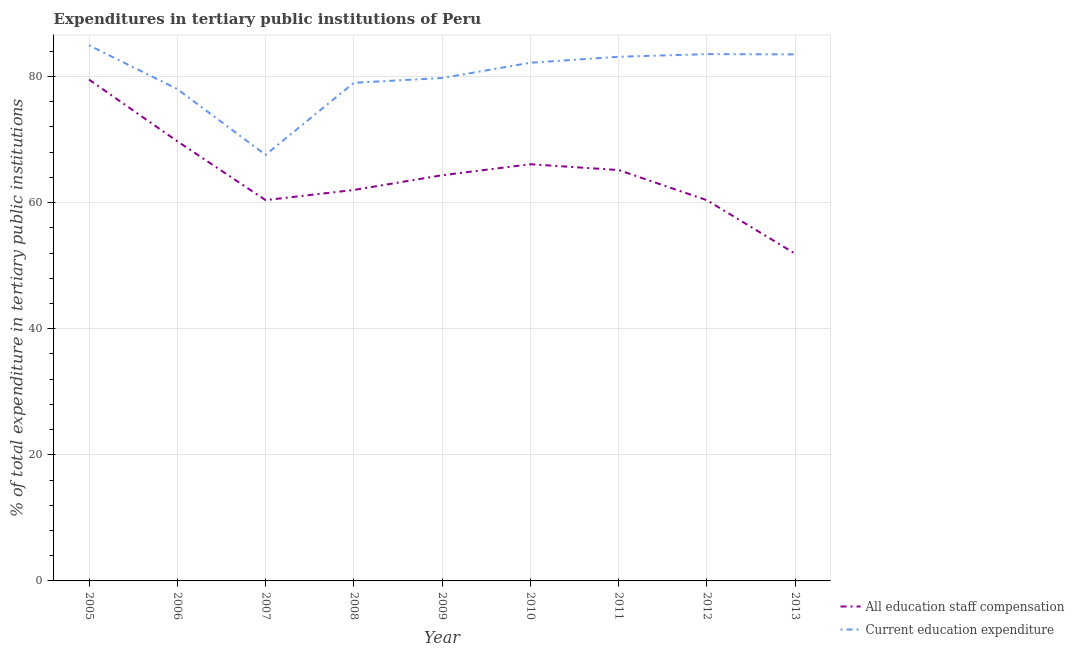Is the number of lines equal to the number of legend labels?
Offer a very short reply. Yes. What is the expenditure in staff compensation in 2012?
Provide a succinct answer. 60.37. Across all years, what is the maximum expenditure in staff compensation?
Your answer should be very brief. 79.5. Across all years, what is the minimum expenditure in education?
Give a very brief answer. 67.57. What is the total expenditure in staff compensation in the graph?
Provide a short and direct response. 579.41. What is the difference between the expenditure in education in 2007 and that in 2010?
Keep it short and to the point. -14.61. What is the difference between the expenditure in staff compensation in 2008 and the expenditure in education in 2005?
Make the answer very short. -22.94. What is the average expenditure in staff compensation per year?
Provide a short and direct response. 64.38. In the year 2013, what is the difference between the expenditure in staff compensation and expenditure in education?
Make the answer very short. -31.62. In how many years, is the expenditure in education greater than 28 %?
Your answer should be compact. 9. What is the ratio of the expenditure in staff compensation in 2008 to that in 2012?
Give a very brief answer. 1.03. What is the difference between the highest and the second highest expenditure in education?
Keep it short and to the point. 1.4. What is the difference between the highest and the lowest expenditure in staff compensation?
Keep it short and to the point. 27.62. In how many years, is the expenditure in education greater than the average expenditure in education taken over all years?
Offer a terse response. 5. Is the sum of the expenditure in staff compensation in 2009 and 2013 greater than the maximum expenditure in education across all years?
Your answer should be very brief. Yes. Does the expenditure in staff compensation monotonically increase over the years?
Your answer should be very brief. No. Is the expenditure in staff compensation strictly greater than the expenditure in education over the years?
Your response must be concise. No. How many lines are there?
Your answer should be compact. 2. How many years are there in the graph?
Your answer should be compact. 9. Are the values on the major ticks of Y-axis written in scientific E-notation?
Offer a very short reply. No. Does the graph contain any zero values?
Give a very brief answer. No. How many legend labels are there?
Keep it short and to the point. 2. What is the title of the graph?
Provide a succinct answer. Expenditures in tertiary public institutions of Peru. Does "Netherlands" appear as one of the legend labels in the graph?
Your response must be concise. No. What is the label or title of the X-axis?
Ensure brevity in your answer.  Year. What is the label or title of the Y-axis?
Provide a short and direct response. % of total expenditure in tertiary public institutions. What is the % of total expenditure in tertiary public institutions of All education staff compensation in 2005?
Provide a succinct answer. 79.5. What is the % of total expenditure in tertiary public institutions in Current education expenditure in 2005?
Ensure brevity in your answer.  84.94. What is the % of total expenditure in tertiary public institutions in All education staff compensation in 2006?
Your answer should be compact. 69.72. What is the % of total expenditure in tertiary public institutions in Current education expenditure in 2006?
Ensure brevity in your answer.  77.99. What is the % of total expenditure in tertiary public institutions of All education staff compensation in 2007?
Provide a succinct answer. 60.39. What is the % of total expenditure in tertiary public institutions of Current education expenditure in 2007?
Your answer should be compact. 67.57. What is the % of total expenditure in tertiary public institutions in All education staff compensation in 2008?
Provide a short and direct response. 61.99. What is the % of total expenditure in tertiary public institutions of Current education expenditure in 2008?
Provide a short and direct response. 78.99. What is the % of total expenditure in tertiary public institutions in All education staff compensation in 2009?
Give a very brief answer. 64.33. What is the % of total expenditure in tertiary public institutions in Current education expenditure in 2009?
Ensure brevity in your answer.  79.75. What is the % of total expenditure in tertiary public institutions of All education staff compensation in 2010?
Your response must be concise. 66.08. What is the % of total expenditure in tertiary public institutions of Current education expenditure in 2010?
Keep it short and to the point. 82.17. What is the % of total expenditure in tertiary public institutions of All education staff compensation in 2011?
Provide a short and direct response. 65.15. What is the % of total expenditure in tertiary public institutions in Current education expenditure in 2011?
Give a very brief answer. 83.12. What is the % of total expenditure in tertiary public institutions in All education staff compensation in 2012?
Provide a short and direct response. 60.37. What is the % of total expenditure in tertiary public institutions in Current education expenditure in 2012?
Ensure brevity in your answer.  83.54. What is the % of total expenditure in tertiary public institutions of All education staff compensation in 2013?
Offer a very short reply. 51.88. What is the % of total expenditure in tertiary public institutions of Current education expenditure in 2013?
Keep it short and to the point. 83.49. Across all years, what is the maximum % of total expenditure in tertiary public institutions in All education staff compensation?
Provide a short and direct response. 79.5. Across all years, what is the maximum % of total expenditure in tertiary public institutions in Current education expenditure?
Provide a succinct answer. 84.94. Across all years, what is the minimum % of total expenditure in tertiary public institutions in All education staff compensation?
Your answer should be compact. 51.88. Across all years, what is the minimum % of total expenditure in tertiary public institutions of Current education expenditure?
Your answer should be very brief. 67.57. What is the total % of total expenditure in tertiary public institutions of All education staff compensation in the graph?
Offer a terse response. 579.41. What is the total % of total expenditure in tertiary public institutions of Current education expenditure in the graph?
Keep it short and to the point. 721.57. What is the difference between the % of total expenditure in tertiary public institutions of All education staff compensation in 2005 and that in 2006?
Give a very brief answer. 9.78. What is the difference between the % of total expenditure in tertiary public institutions of Current education expenditure in 2005 and that in 2006?
Your response must be concise. 6.94. What is the difference between the % of total expenditure in tertiary public institutions of All education staff compensation in 2005 and that in 2007?
Your response must be concise. 19.11. What is the difference between the % of total expenditure in tertiary public institutions in Current education expenditure in 2005 and that in 2007?
Offer a terse response. 17.37. What is the difference between the % of total expenditure in tertiary public institutions in All education staff compensation in 2005 and that in 2008?
Give a very brief answer. 17.5. What is the difference between the % of total expenditure in tertiary public institutions in Current education expenditure in 2005 and that in 2008?
Your answer should be compact. 5.94. What is the difference between the % of total expenditure in tertiary public institutions of All education staff compensation in 2005 and that in 2009?
Provide a short and direct response. 15.16. What is the difference between the % of total expenditure in tertiary public institutions in Current education expenditure in 2005 and that in 2009?
Provide a succinct answer. 5.19. What is the difference between the % of total expenditure in tertiary public institutions of All education staff compensation in 2005 and that in 2010?
Make the answer very short. 13.42. What is the difference between the % of total expenditure in tertiary public institutions in Current education expenditure in 2005 and that in 2010?
Give a very brief answer. 2.76. What is the difference between the % of total expenditure in tertiary public institutions of All education staff compensation in 2005 and that in 2011?
Your answer should be compact. 14.34. What is the difference between the % of total expenditure in tertiary public institutions in Current education expenditure in 2005 and that in 2011?
Your response must be concise. 1.82. What is the difference between the % of total expenditure in tertiary public institutions of All education staff compensation in 2005 and that in 2012?
Offer a very short reply. 19.13. What is the difference between the % of total expenditure in tertiary public institutions of Current education expenditure in 2005 and that in 2012?
Ensure brevity in your answer.  1.4. What is the difference between the % of total expenditure in tertiary public institutions of All education staff compensation in 2005 and that in 2013?
Offer a terse response. 27.62. What is the difference between the % of total expenditure in tertiary public institutions of Current education expenditure in 2005 and that in 2013?
Keep it short and to the point. 1.44. What is the difference between the % of total expenditure in tertiary public institutions in All education staff compensation in 2006 and that in 2007?
Ensure brevity in your answer.  9.33. What is the difference between the % of total expenditure in tertiary public institutions in Current education expenditure in 2006 and that in 2007?
Your answer should be very brief. 10.43. What is the difference between the % of total expenditure in tertiary public institutions of All education staff compensation in 2006 and that in 2008?
Your answer should be very brief. 7.73. What is the difference between the % of total expenditure in tertiary public institutions in Current education expenditure in 2006 and that in 2008?
Offer a very short reply. -1. What is the difference between the % of total expenditure in tertiary public institutions of All education staff compensation in 2006 and that in 2009?
Your answer should be compact. 5.39. What is the difference between the % of total expenditure in tertiary public institutions of Current education expenditure in 2006 and that in 2009?
Provide a succinct answer. -1.76. What is the difference between the % of total expenditure in tertiary public institutions of All education staff compensation in 2006 and that in 2010?
Offer a very short reply. 3.64. What is the difference between the % of total expenditure in tertiary public institutions of Current education expenditure in 2006 and that in 2010?
Give a very brief answer. -4.18. What is the difference between the % of total expenditure in tertiary public institutions of All education staff compensation in 2006 and that in 2011?
Your answer should be very brief. 4.57. What is the difference between the % of total expenditure in tertiary public institutions in Current education expenditure in 2006 and that in 2011?
Provide a succinct answer. -5.13. What is the difference between the % of total expenditure in tertiary public institutions of All education staff compensation in 2006 and that in 2012?
Your answer should be compact. 9.35. What is the difference between the % of total expenditure in tertiary public institutions of Current education expenditure in 2006 and that in 2012?
Provide a succinct answer. -5.54. What is the difference between the % of total expenditure in tertiary public institutions of All education staff compensation in 2006 and that in 2013?
Give a very brief answer. 17.84. What is the difference between the % of total expenditure in tertiary public institutions in Current education expenditure in 2006 and that in 2013?
Give a very brief answer. -5.5. What is the difference between the % of total expenditure in tertiary public institutions of All education staff compensation in 2007 and that in 2008?
Your answer should be very brief. -1.61. What is the difference between the % of total expenditure in tertiary public institutions in Current education expenditure in 2007 and that in 2008?
Give a very brief answer. -11.43. What is the difference between the % of total expenditure in tertiary public institutions of All education staff compensation in 2007 and that in 2009?
Ensure brevity in your answer.  -3.94. What is the difference between the % of total expenditure in tertiary public institutions of Current education expenditure in 2007 and that in 2009?
Give a very brief answer. -12.18. What is the difference between the % of total expenditure in tertiary public institutions of All education staff compensation in 2007 and that in 2010?
Your answer should be compact. -5.69. What is the difference between the % of total expenditure in tertiary public institutions in Current education expenditure in 2007 and that in 2010?
Provide a succinct answer. -14.61. What is the difference between the % of total expenditure in tertiary public institutions of All education staff compensation in 2007 and that in 2011?
Provide a succinct answer. -4.77. What is the difference between the % of total expenditure in tertiary public institutions of Current education expenditure in 2007 and that in 2011?
Offer a very short reply. -15.55. What is the difference between the % of total expenditure in tertiary public institutions of Current education expenditure in 2007 and that in 2012?
Give a very brief answer. -15.97. What is the difference between the % of total expenditure in tertiary public institutions in All education staff compensation in 2007 and that in 2013?
Offer a very short reply. 8.51. What is the difference between the % of total expenditure in tertiary public institutions of Current education expenditure in 2007 and that in 2013?
Provide a short and direct response. -15.93. What is the difference between the % of total expenditure in tertiary public institutions in All education staff compensation in 2008 and that in 2009?
Ensure brevity in your answer.  -2.34. What is the difference between the % of total expenditure in tertiary public institutions in Current education expenditure in 2008 and that in 2009?
Ensure brevity in your answer.  -0.76. What is the difference between the % of total expenditure in tertiary public institutions of All education staff compensation in 2008 and that in 2010?
Your answer should be very brief. -4.08. What is the difference between the % of total expenditure in tertiary public institutions in Current education expenditure in 2008 and that in 2010?
Provide a succinct answer. -3.18. What is the difference between the % of total expenditure in tertiary public institutions in All education staff compensation in 2008 and that in 2011?
Provide a short and direct response. -3.16. What is the difference between the % of total expenditure in tertiary public institutions in Current education expenditure in 2008 and that in 2011?
Keep it short and to the point. -4.13. What is the difference between the % of total expenditure in tertiary public institutions in All education staff compensation in 2008 and that in 2012?
Your response must be concise. 1.63. What is the difference between the % of total expenditure in tertiary public institutions of Current education expenditure in 2008 and that in 2012?
Your answer should be compact. -4.54. What is the difference between the % of total expenditure in tertiary public institutions in All education staff compensation in 2008 and that in 2013?
Provide a short and direct response. 10.12. What is the difference between the % of total expenditure in tertiary public institutions in Current education expenditure in 2008 and that in 2013?
Your answer should be compact. -4.5. What is the difference between the % of total expenditure in tertiary public institutions in All education staff compensation in 2009 and that in 2010?
Give a very brief answer. -1.75. What is the difference between the % of total expenditure in tertiary public institutions in Current education expenditure in 2009 and that in 2010?
Offer a very short reply. -2.42. What is the difference between the % of total expenditure in tertiary public institutions in All education staff compensation in 2009 and that in 2011?
Offer a terse response. -0.82. What is the difference between the % of total expenditure in tertiary public institutions of Current education expenditure in 2009 and that in 2011?
Offer a very short reply. -3.37. What is the difference between the % of total expenditure in tertiary public institutions in All education staff compensation in 2009 and that in 2012?
Make the answer very short. 3.96. What is the difference between the % of total expenditure in tertiary public institutions of Current education expenditure in 2009 and that in 2012?
Provide a succinct answer. -3.79. What is the difference between the % of total expenditure in tertiary public institutions of All education staff compensation in 2009 and that in 2013?
Provide a succinct answer. 12.45. What is the difference between the % of total expenditure in tertiary public institutions of Current education expenditure in 2009 and that in 2013?
Offer a terse response. -3.74. What is the difference between the % of total expenditure in tertiary public institutions in All education staff compensation in 2010 and that in 2011?
Keep it short and to the point. 0.92. What is the difference between the % of total expenditure in tertiary public institutions of Current education expenditure in 2010 and that in 2011?
Offer a terse response. -0.95. What is the difference between the % of total expenditure in tertiary public institutions in All education staff compensation in 2010 and that in 2012?
Keep it short and to the point. 5.71. What is the difference between the % of total expenditure in tertiary public institutions in Current education expenditure in 2010 and that in 2012?
Offer a terse response. -1.37. What is the difference between the % of total expenditure in tertiary public institutions of All education staff compensation in 2010 and that in 2013?
Give a very brief answer. 14.2. What is the difference between the % of total expenditure in tertiary public institutions of Current education expenditure in 2010 and that in 2013?
Give a very brief answer. -1.32. What is the difference between the % of total expenditure in tertiary public institutions of All education staff compensation in 2011 and that in 2012?
Provide a short and direct response. 4.79. What is the difference between the % of total expenditure in tertiary public institutions of Current education expenditure in 2011 and that in 2012?
Make the answer very short. -0.42. What is the difference between the % of total expenditure in tertiary public institutions in All education staff compensation in 2011 and that in 2013?
Your answer should be very brief. 13.28. What is the difference between the % of total expenditure in tertiary public institutions of Current education expenditure in 2011 and that in 2013?
Your answer should be compact. -0.37. What is the difference between the % of total expenditure in tertiary public institutions of All education staff compensation in 2012 and that in 2013?
Keep it short and to the point. 8.49. What is the difference between the % of total expenditure in tertiary public institutions in Current education expenditure in 2012 and that in 2013?
Give a very brief answer. 0.04. What is the difference between the % of total expenditure in tertiary public institutions in All education staff compensation in 2005 and the % of total expenditure in tertiary public institutions in Current education expenditure in 2006?
Make the answer very short. 1.5. What is the difference between the % of total expenditure in tertiary public institutions in All education staff compensation in 2005 and the % of total expenditure in tertiary public institutions in Current education expenditure in 2007?
Provide a short and direct response. 11.93. What is the difference between the % of total expenditure in tertiary public institutions of All education staff compensation in 2005 and the % of total expenditure in tertiary public institutions of Current education expenditure in 2008?
Provide a short and direct response. 0.5. What is the difference between the % of total expenditure in tertiary public institutions in All education staff compensation in 2005 and the % of total expenditure in tertiary public institutions in Current education expenditure in 2009?
Offer a very short reply. -0.26. What is the difference between the % of total expenditure in tertiary public institutions in All education staff compensation in 2005 and the % of total expenditure in tertiary public institutions in Current education expenditure in 2010?
Offer a very short reply. -2.68. What is the difference between the % of total expenditure in tertiary public institutions of All education staff compensation in 2005 and the % of total expenditure in tertiary public institutions of Current education expenditure in 2011?
Provide a succinct answer. -3.62. What is the difference between the % of total expenditure in tertiary public institutions of All education staff compensation in 2005 and the % of total expenditure in tertiary public institutions of Current education expenditure in 2012?
Your answer should be very brief. -4.04. What is the difference between the % of total expenditure in tertiary public institutions in All education staff compensation in 2005 and the % of total expenditure in tertiary public institutions in Current education expenditure in 2013?
Make the answer very short. -4. What is the difference between the % of total expenditure in tertiary public institutions in All education staff compensation in 2006 and the % of total expenditure in tertiary public institutions in Current education expenditure in 2007?
Your response must be concise. 2.15. What is the difference between the % of total expenditure in tertiary public institutions in All education staff compensation in 2006 and the % of total expenditure in tertiary public institutions in Current education expenditure in 2008?
Your response must be concise. -9.27. What is the difference between the % of total expenditure in tertiary public institutions of All education staff compensation in 2006 and the % of total expenditure in tertiary public institutions of Current education expenditure in 2009?
Give a very brief answer. -10.03. What is the difference between the % of total expenditure in tertiary public institutions of All education staff compensation in 2006 and the % of total expenditure in tertiary public institutions of Current education expenditure in 2010?
Your response must be concise. -12.45. What is the difference between the % of total expenditure in tertiary public institutions in All education staff compensation in 2006 and the % of total expenditure in tertiary public institutions in Current education expenditure in 2011?
Ensure brevity in your answer.  -13.4. What is the difference between the % of total expenditure in tertiary public institutions in All education staff compensation in 2006 and the % of total expenditure in tertiary public institutions in Current education expenditure in 2012?
Your answer should be compact. -13.82. What is the difference between the % of total expenditure in tertiary public institutions of All education staff compensation in 2006 and the % of total expenditure in tertiary public institutions of Current education expenditure in 2013?
Keep it short and to the point. -13.77. What is the difference between the % of total expenditure in tertiary public institutions of All education staff compensation in 2007 and the % of total expenditure in tertiary public institutions of Current education expenditure in 2008?
Provide a short and direct response. -18.61. What is the difference between the % of total expenditure in tertiary public institutions of All education staff compensation in 2007 and the % of total expenditure in tertiary public institutions of Current education expenditure in 2009?
Offer a terse response. -19.36. What is the difference between the % of total expenditure in tertiary public institutions in All education staff compensation in 2007 and the % of total expenditure in tertiary public institutions in Current education expenditure in 2010?
Provide a short and direct response. -21.78. What is the difference between the % of total expenditure in tertiary public institutions in All education staff compensation in 2007 and the % of total expenditure in tertiary public institutions in Current education expenditure in 2011?
Your response must be concise. -22.73. What is the difference between the % of total expenditure in tertiary public institutions of All education staff compensation in 2007 and the % of total expenditure in tertiary public institutions of Current education expenditure in 2012?
Provide a short and direct response. -23.15. What is the difference between the % of total expenditure in tertiary public institutions in All education staff compensation in 2007 and the % of total expenditure in tertiary public institutions in Current education expenditure in 2013?
Ensure brevity in your answer.  -23.11. What is the difference between the % of total expenditure in tertiary public institutions in All education staff compensation in 2008 and the % of total expenditure in tertiary public institutions in Current education expenditure in 2009?
Give a very brief answer. -17.76. What is the difference between the % of total expenditure in tertiary public institutions in All education staff compensation in 2008 and the % of total expenditure in tertiary public institutions in Current education expenditure in 2010?
Offer a very short reply. -20.18. What is the difference between the % of total expenditure in tertiary public institutions in All education staff compensation in 2008 and the % of total expenditure in tertiary public institutions in Current education expenditure in 2011?
Keep it short and to the point. -21.13. What is the difference between the % of total expenditure in tertiary public institutions in All education staff compensation in 2008 and the % of total expenditure in tertiary public institutions in Current education expenditure in 2012?
Keep it short and to the point. -21.54. What is the difference between the % of total expenditure in tertiary public institutions in All education staff compensation in 2008 and the % of total expenditure in tertiary public institutions in Current education expenditure in 2013?
Ensure brevity in your answer.  -21.5. What is the difference between the % of total expenditure in tertiary public institutions in All education staff compensation in 2009 and the % of total expenditure in tertiary public institutions in Current education expenditure in 2010?
Give a very brief answer. -17.84. What is the difference between the % of total expenditure in tertiary public institutions in All education staff compensation in 2009 and the % of total expenditure in tertiary public institutions in Current education expenditure in 2011?
Your response must be concise. -18.79. What is the difference between the % of total expenditure in tertiary public institutions of All education staff compensation in 2009 and the % of total expenditure in tertiary public institutions of Current education expenditure in 2012?
Give a very brief answer. -19.21. What is the difference between the % of total expenditure in tertiary public institutions of All education staff compensation in 2009 and the % of total expenditure in tertiary public institutions of Current education expenditure in 2013?
Offer a very short reply. -19.16. What is the difference between the % of total expenditure in tertiary public institutions in All education staff compensation in 2010 and the % of total expenditure in tertiary public institutions in Current education expenditure in 2011?
Your answer should be compact. -17.04. What is the difference between the % of total expenditure in tertiary public institutions in All education staff compensation in 2010 and the % of total expenditure in tertiary public institutions in Current education expenditure in 2012?
Keep it short and to the point. -17.46. What is the difference between the % of total expenditure in tertiary public institutions of All education staff compensation in 2010 and the % of total expenditure in tertiary public institutions of Current education expenditure in 2013?
Your response must be concise. -17.42. What is the difference between the % of total expenditure in tertiary public institutions in All education staff compensation in 2011 and the % of total expenditure in tertiary public institutions in Current education expenditure in 2012?
Ensure brevity in your answer.  -18.38. What is the difference between the % of total expenditure in tertiary public institutions in All education staff compensation in 2011 and the % of total expenditure in tertiary public institutions in Current education expenditure in 2013?
Your answer should be compact. -18.34. What is the difference between the % of total expenditure in tertiary public institutions in All education staff compensation in 2012 and the % of total expenditure in tertiary public institutions in Current education expenditure in 2013?
Provide a short and direct response. -23.13. What is the average % of total expenditure in tertiary public institutions of All education staff compensation per year?
Give a very brief answer. 64.38. What is the average % of total expenditure in tertiary public institutions in Current education expenditure per year?
Offer a terse response. 80.17. In the year 2005, what is the difference between the % of total expenditure in tertiary public institutions of All education staff compensation and % of total expenditure in tertiary public institutions of Current education expenditure?
Offer a terse response. -5.44. In the year 2006, what is the difference between the % of total expenditure in tertiary public institutions in All education staff compensation and % of total expenditure in tertiary public institutions in Current education expenditure?
Keep it short and to the point. -8.27. In the year 2007, what is the difference between the % of total expenditure in tertiary public institutions in All education staff compensation and % of total expenditure in tertiary public institutions in Current education expenditure?
Your answer should be very brief. -7.18. In the year 2008, what is the difference between the % of total expenditure in tertiary public institutions of All education staff compensation and % of total expenditure in tertiary public institutions of Current education expenditure?
Offer a very short reply. -17. In the year 2009, what is the difference between the % of total expenditure in tertiary public institutions in All education staff compensation and % of total expenditure in tertiary public institutions in Current education expenditure?
Your answer should be very brief. -15.42. In the year 2010, what is the difference between the % of total expenditure in tertiary public institutions of All education staff compensation and % of total expenditure in tertiary public institutions of Current education expenditure?
Provide a short and direct response. -16.1. In the year 2011, what is the difference between the % of total expenditure in tertiary public institutions in All education staff compensation and % of total expenditure in tertiary public institutions in Current education expenditure?
Your response must be concise. -17.97. In the year 2012, what is the difference between the % of total expenditure in tertiary public institutions of All education staff compensation and % of total expenditure in tertiary public institutions of Current education expenditure?
Your answer should be compact. -23.17. In the year 2013, what is the difference between the % of total expenditure in tertiary public institutions of All education staff compensation and % of total expenditure in tertiary public institutions of Current education expenditure?
Your response must be concise. -31.62. What is the ratio of the % of total expenditure in tertiary public institutions of All education staff compensation in 2005 to that in 2006?
Offer a terse response. 1.14. What is the ratio of the % of total expenditure in tertiary public institutions of Current education expenditure in 2005 to that in 2006?
Provide a succinct answer. 1.09. What is the ratio of the % of total expenditure in tertiary public institutions in All education staff compensation in 2005 to that in 2007?
Provide a succinct answer. 1.32. What is the ratio of the % of total expenditure in tertiary public institutions in Current education expenditure in 2005 to that in 2007?
Your answer should be very brief. 1.26. What is the ratio of the % of total expenditure in tertiary public institutions in All education staff compensation in 2005 to that in 2008?
Your answer should be compact. 1.28. What is the ratio of the % of total expenditure in tertiary public institutions of Current education expenditure in 2005 to that in 2008?
Provide a succinct answer. 1.08. What is the ratio of the % of total expenditure in tertiary public institutions of All education staff compensation in 2005 to that in 2009?
Your response must be concise. 1.24. What is the ratio of the % of total expenditure in tertiary public institutions in Current education expenditure in 2005 to that in 2009?
Make the answer very short. 1.06. What is the ratio of the % of total expenditure in tertiary public institutions of All education staff compensation in 2005 to that in 2010?
Ensure brevity in your answer.  1.2. What is the ratio of the % of total expenditure in tertiary public institutions in Current education expenditure in 2005 to that in 2010?
Your answer should be very brief. 1.03. What is the ratio of the % of total expenditure in tertiary public institutions in All education staff compensation in 2005 to that in 2011?
Your response must be concise. 1.22. What is the ratio of the % of total expenditure in tertiary public institutions of Current education expenditure in 2005 to that in 2011?
Ensure brevity in your answer.  1.02. What is the ratio of the % of total expenditure in tertiary public institutions of All education staff compensation in 2005 to that in 2012?
Ensure brevity in your answer.  1.32. What is the ratio of the % of total expenditure in tertiary public institutions of Current education expenditure in 2005 to that in 2012?
Provide a succinct answer. 1.02. What is the ratio of the % of total expenditure in tertiary public institutions in All education staff compensation in 2005 to that in 2013?
Provide a succinct answer. 1.53. What is the ratio of the % of total expenditure in tertiary public institutions in Current education expenditure in 2005 to that in 2013?
Your answer should be compact. 1.02. What is the ratio of the % of total expenditure in tertiary public institutions of All education staff compensation in 2006 to that in 2007?
Keep it short and to the point. 1.15. What is the ratio of the % of total expenditure in tertiary public institutions in Current education expenditure in 2006 to that in 2007?
Provide a succinct answer. 1.15. What is the ratio of the % of total expenditure in tertiary public institutions in All education staff compensation in 2006 to that in 2008?
Your response must be concise. 1.12. What is the ratio of the % of total expenditure in tertiary public institutions of Current education expenditure in 2006 to that in 2008?
Make the answer very short. 0.99. What is the ratio of the % of total expenditure in tertiary public institutions of All education staff compensation in 2006 to that in 2009?
Ensure brevity in your answer.  1.08. What is the ratio of the % of total expenditure in tertiary public institutions in All education staff compensation in 2006 to that in 2010?
Give a very brief answer. 1.06. What is the ratio of the % of total expenditure in tertiary public institutions in Current education expenditure in 2006 to that in 2010?
Give a very brief answer. 0.95. What is the ratio of the % of total expenditure in tertiary public institutions of All education staff compensation in 2006 to that in 2011?
Provide a succinct answer. 1.07. What is the ratio of the % of total expenditure in tertiary public institutions in Current education expenditure in 2006 to that in 2011?
Keep it short and to the point. 0.94. What is the ratio of the % of total expenditure in tertiary public institutions of All education staff compensation in 2006 to that in 2012?
Offer a very short reply. 1.15. What is the ratio of the % of total expenditure in tertiary public institutions of Current education expenditure in 2006 to that in 2012?
Your response must be concise. 0.93. What is the ratio of the % of total expenditure in tertiary public institutions of All education staff compensation in 2006 to that in 2013?
Ensure brevity in your answer.  1.34. What is the ratio of the % of total expenditure in tertiary public institutions in Current education expenditure in 2006 to that in 2013?
Keep it short and to the point. 0.93. What is the ratio of the % of total expenditure in tertiary public institutions in All education staff compensation in 2007 to that in 2008?
Make the answer very short. 0.97. What is the ratio of the % of total expenditure in tertiary public institutions of Current education expenditure in 2007 to that in 2008?
Offer a very short reply. 0.86. What is the ratio of the % of total expenditure in tertiary public institutions in All education staff compensation in 2007 to that in 2009?
Offer a very short reply. 0.94. What is the ratio of the % of total expenditure in tertiary public institutions in Current education expenditure in 2007 to that in 2009?
Offer a terse response. 0.85. What is the ratio of the % of total expenditure in tertiary public institutions of All education staff compensation in 2007 to that in 2010?
Provide a short and direct response. 0.91. What is the ratio of the % of total expenditure in tertiary public institutions in Current education expenditure in 2007 to that in 2010?
Provide a succinct answer. 0.82. What is the ratio of the % of total expenditure in tertiary public institutions in All education staff compensation in 2007 to that in 2011?
Provide a succinct answer. 0.93. What is the ratio of the % of total expenditure in tertiary public institutions in Current education expenditure in 2007 to that in 2011?
Your response must be concise. 0.81. What is the ratio of the % of total expenditure in tertiary public institutions of Current education expenditure in 2007 to that in 2012?
Offer a very short reply. 0.81. What is the ratio of the % of total expenditure in tertiary public institutions in All education staff compensation in 2007 to that in 2013?
Your answer should be very brief. 1.16. What is the ratio of the % of total expenditure in tertiary public institutions in Current education expenditure in 2007 to that in 2013?
Keep it short and to the point. 0.81. What is the ratio of the % of total expenditure in tertiary public institutions in All education staff compensation in 2008 to that in 2009?
Ensure brevity in your answer.  0.96. What is the ratio of the % of total expenditure in tertiary public institutions of Current education expenditure in 2008 to that in 2009?
Ensure brevity in your answer.  0.99. What is the ratio of the % of total expenditure in tertiary public institutions in All education staff compensation in 2008 to that in 2010?
Your answer should be compact. 0.94. What is the ratio of the % of total expenditure in tertiary public institutions of Current education expenditure in 2008 to that in 2010?
Provide a short and direct response. 0.96. What is the ratio of the % of total expenditure in tertiary public institutions of All education staff compensation in 2008 to that in 2011?
Your answer should be compact. 0.95. What is the ratio of the % of total expenditure in tertiary public institutions in Current education expenditure in 2008 to that in 2011?
Your answer should be compact. 0.95. What is the ratio of the % of total expenditure in tertiary public institutions in All education staff compensation in 2008 to that in 2012?
Keep it short and to the point. 1.03. What is the ratio of the % of total expenditure in tertiary public institutions of Current education expenditure in 2008 to that in 2012?
Offer a terse response. 0.95. What is the ratio of the % of total expenditure in tertiary public institutions in All education staff compensation in 2008 to that in 2013?
Provide a short and direct response. 1.2. What is the ratio of the % of total expenditure in tertiary public institutions in Current education expenditure in 2008 to that in 2013?
Give a very brief answer. 0.95. What is the ratio of the % of total expenditure in tertiary public institutions of All education staff compensation in 2009 to that in 2010?
Provide a short and direct response. 0.97. What is the ratio of the % of total expenditure in tertiary public institutions of Current education expenditure in 2009 to that in 2010?
Your response must be concise. 0.97. What is the ratio of the % of total expenditure in tertiary public institutions of All education staff compensation in 2009 to that in 2011?
Your response must be concise. 0.99. What is the ratio of the % of total expenditure in tertiary public institutions of Current education expenditure in 2009 to that in 2011?
Offer a very short reply. 0.96. What is the ratio of the % of total expenditure in tertiary public institutions in All education staff compensation in 2009 to that in 2012?
Offer a terse response. 1.07. What is the ratio of the % of total expenditure in tertiary public institutions in Current education expenditure in 2009 to that in 2012?
Offer a terse response. 0.95. What is the ratio of the % of total expenditure in tertiary public institutions of All education staff compensation in 2009 to that in 2013?
Give a very brief answer. 1.24. What is the ratio of the % of total expenditure in tertiary public institutions in Current education expenditure in 2009 to that in 2013?
Give a very brief answer. 0.96. What is the ratio of the % of total expenditure in tertiary public institutions of All education staff compensation in 2010 to that in 2011?
Make the answer very short. 1.01. What is the ratio of the % of total expenditure in tertiary public institutions of All education staff compensation in 2010 to that in 2012?
Offer a terse response. 1.09. What is the ratio of the % of total expenditure in tertiary public institutions of Current education expenditure in 2010 to that in 2012?
Offer a terse response. 0.98. What is the ratio of the % of total expenditure in tertiary public institutions of All education staff compensation in 2010 to that in 2013?
Offer a terse response. 1.27. What is the ratio of the % of total expenditure in tertiary public institutions of Current education expenditure in 2010 to that in 2013?
Provide a short and direct response. 0.98. What is the ratio of the % of total expenditure in tertiary public institutions of All education staff compensation in 2011 to that in 2012?
Your answer should be very brief. 1.08. What is the ratio of the % of total expenditure in tertiary public institutions of Current education expenditure in 2011 to that in 2012?
Offer a very short reply. 0.99. What is the ratio of the % of total expenditure in tertiary public institutions of All education staff compensation in 2011 to that in 2013?
Provide a succinct answer. 1.26. What is the ratio of the % of total expenditure in tertiary public institutions of All education staff compensation in 2012 to that in 2013?
Ensure brevity in your answer.  1.16. What is the difference between the highest and the second highest % of total expenditure in tertiary public institutions in All education staff compensation?
Provide a succinct answer. 9.78. What is the difference between the highest and the second highest % of total expenditure in tertiary public institutions in Current education expenditure?
Offer a very short reply. 1.4. What is the difference between the highest and the lowest % of total expenditure in tertiary public institutions of All education staff compensation?
Keep it short and to the point. 27.62. What is the difference between the highest and the lowest % of total expenditure in tertiary public institutions in Current education expenditure?
Ensure brevity in your answer.  17.37. 